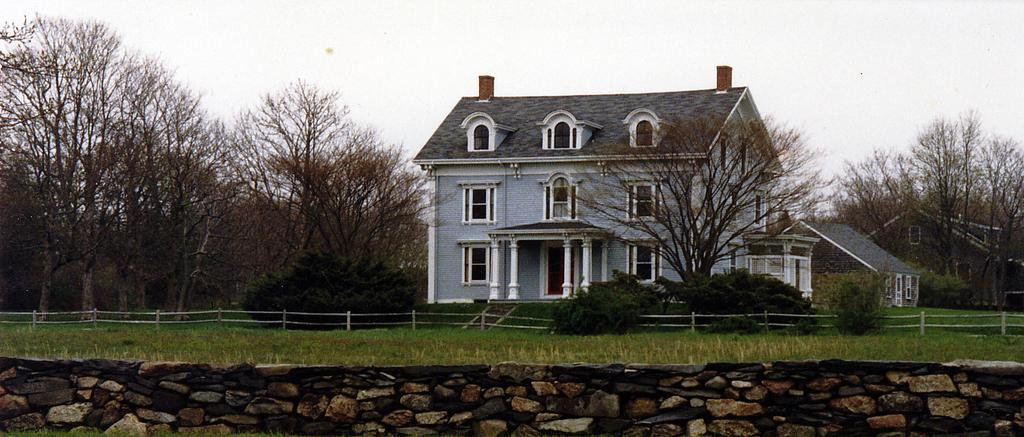What type of structure is visible in the image? There is a house in the image. What type of vegetation can be seen in the image? There are trees in the image. What is covering the ground in the image? There is grass on the ground in the image. What is the condition of the sky in the image? The sky is cloudy in the image. Where is the cave located in the image? There is no cave present in the image. What type of birth can be observed in the image? There is no birth present in the image. 